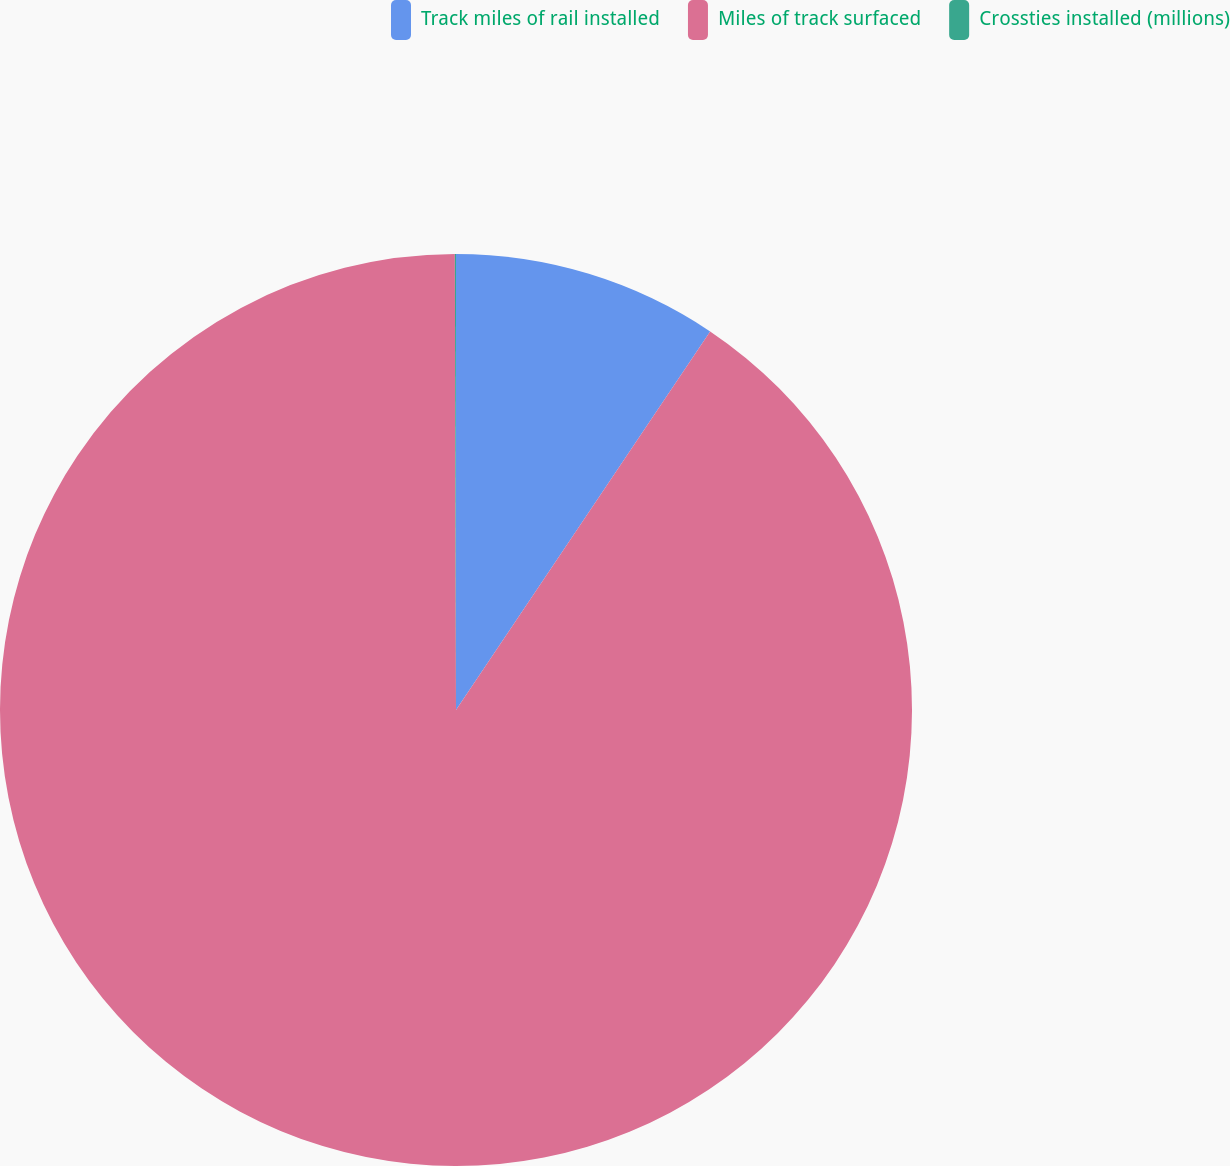<chart> <loc_0><loc_0><loc_500><loc_500><pie_chart><fcel>Track miles of rail installed<fcel>Miles of track surfaced<fcel>Crossties installed (millions)<nl><fcel>9.41%<fcel>90.55%<fcel>0.04%<nl></chart> 